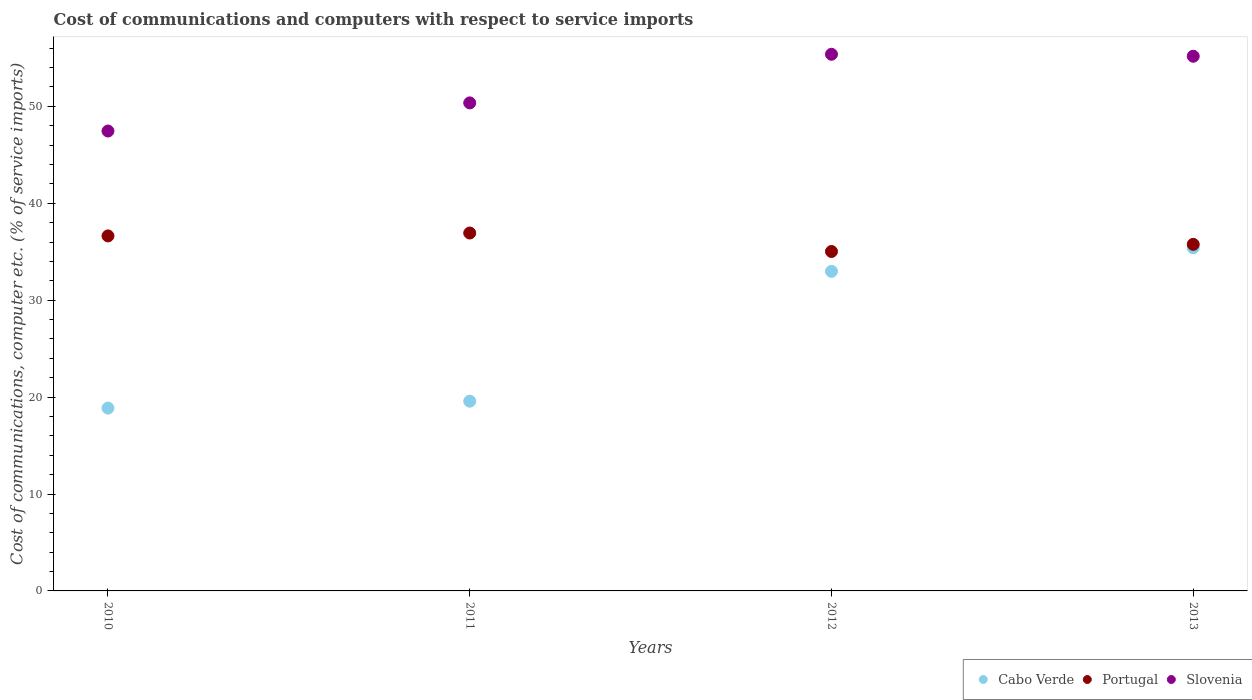How many different coloured dotlines are there?
Your answer should be compact. 3. What is the cost of communications and computers in Slovenia in 2011?
Your response must be concise. 50.35. Across all years, what is the maximum cost of communications and computers in Slovenia?
Provide a short and direct response. 55.37. Across all years, what is the minimum cost of communications and computers in Portugal?
Offer a terse response. 35.02. What is the total cost of communications and computers in Portugal in the graph?
Your answer should be compact. 144.34. What is the difference between the cost of communications and computers in Slovenia in 2010 and that in 2011?
Make the answer very short. -2.9. What is the difference between the cost of communications and computers in Cabo Verde in 2011 and the cost of communications and computers in Slovenia in 2010?
Your answer should be compact. -27.87. What is the average cost of communications and computers in Cabo Verde per year?
Your answer should be compact. 26.7. In the year 2012, what is the difference between the cost of communications and computers in Portugal and cost of communications and computers in Slovenia?
Your answer should be very brief. -20.35. What is the ratio of the cost of communications and computers in Slovenia in 2010 to that in 2011?
Keep it short and to the point. 0.94. Is the difference between the cost of communications and computers in Portugal in 2010 and 2012 greater than the difference between the cost of communications and computers in Slovenia in 2010 and 2012?
Offer a terse response. Yes. What is the difference between the highest and the second highest cost of communications and computers in Cabo Verde?
Make the answer very short. 2.43. What is the difference between the highest and the lowest cost of communications and computers in Portugal?
Offer a terse response. 1.91. Is the cost of communications and computers in Portugal strictly greater than the cost of communications and computers in Cabo Verde over the years?
Make the answer very short. Yes. How many years are there in the graph?
Provide a short and direct response. 4. Are the values on the major ticks of Y-axis written in scientific E-notation?
Provide a short and direct response. No. Does the graph contain grids?
Your answer should be very brief. No. Where does the legend appear in the graph?
Give a very brief answer. Bottom right. How many legend labels are there?
Your answer should be compact. 3. How are the legend labels stacked?
Make the answer very short. Horizontal. What is the title of the graph?
Ensure brevity in your answer.  Cost of communications and computers with respect to service imports. Does "Cabo Verde" appear as one of the legend labels in the graph?
Your answer should be compact. Yes. What is the label or title of the X-axis?
Provide a short and direct response. Years. What is the label or title of the Y-axis?
Ensure brevity in your answer.  Cost of communications, computer etc. (% of service imports). What is the Cost of communications, computer etc. (% of service imports) of Cabo Verde in 2010?
Your answer should be very brief. 18.86. What is the Cost of communications, computer etc. (% of service imports) of Portugal in 2010?
Provide a short and direct response. 36.63. What is the Cost of communications, computer etc. (% of service imports) of Slovenia in 2010?
Your answer should be compact. 47.45. What is the Cost of communications, computer etc. (% of service imports) of Cabo Verde in 2011?
Give a very brief answer. 19.58. What is the Cost of communications, computer etc. (% of service imports) in Portugal in 2011?
Provide a succinct answer. 36.93. What is the Cost of communications, computer etc. (% of service imports) in Slovenia in 2011?
Give a very brief answer. 50.35. What is the Cost of communications, computer etc. (% of service imports) in Cabo Verde in 2012?
Your response must be concise. 32.97. What is the Cost of communications, computer etc. (% of service imports) in Portugal in 2012?
Provide a succinct answer. 35.02. What is the Cost of communications, computer etc. (% of service imports) of Slovenia in 2012?
Offer a terse response. 55.37. What is the Cost of communications, computer etc. (% of service imports) of Cabo Verde in 2013?
Offer a terse response. 35.4. What is the Cost of communications, computer etc. (% of service imports) of Portugal in 2013?
Make the answer very short. 35.76. What is the Cost of communications, computer etc. (% of service imports) of Slovenia in 2013?
Offer a terse response. 55.17. Across all years, what is the maximum Cost of communications, computer etc. (% of service imports) in Cabo Verde?
Offer a very short reply. 35.4. Across all years, what is the maximum Cost of communications, computer etc. (% of service imports) of Portugal?
Offer a terse response. 36.93. Across all years, what is the maximum Cost of communications, computer etc. (% of service imports) in Slovenia?
Give a very brief answer. 55.37. Across all years, what is the minimum Cost of communications, computer etc. (% of service imports) in Cabo Verde?
Keep it short and to the point. 18.86. Across all years, what is the minimum Cost of communications, computer etc. (% of service imports) in Portugal?
Offer a very short reply. 35.02. Across all years, what is the minimum Cost of communications, computer etc. (% of service imports) of Slovenia?
Your answer should be compact. 47.45. What is the total Cost of communications, computer etc. (% of service imports) of Cabo Verde in the graph?
Your answer should be compact. 106.81. What is the total Cost of communications, computer etc. (% of service imports) of Portugal in the graph?
Provide a succinct answer. 144.34. What is the total Cost of communications, computer etc. (% of service imports) of Slovenia in the graph?
Keep it short and to the point. 208.34. What is the difference between the Cost of communications, computer etc. (% of service imports) in Cabo Verde in 2010 and that in 2011?
Provide a short and direct response. -0.71. What is the difference between the Cost of communications, computer etc. (% of service imports) in Portugal in 2010 and that in 2011?
Your response must be concise. -0.3. What is the difference between the Cost of communications, computer etc. (% of service imports) in Slovenia in 2010 and that in 2011?
Your answer should be compact. -2.9. What is the difference between the Cost of communications, computer etc. (% of service imports) in Cabo Verde in 2010 and that in 2012?
Your answer should be compact. -14.11. What is the difference between the Cost of communications, computer etc. (% of service imports) in Portugal in 2010 and that in 2012?
Offer a terse response. 1.61. What is the difference between the Cost of communications, computer etc. (% of service imports) in Slovenia in 2010 and that in 2012?
Your answer should be compact. -7.92. What is the difference between the Cost of communications, computer etc. (% of service imports) in Cabo Verde in 2010 and that in 2013?
Provide a succinct answer. -16.54. What is the difference between the Cost of communications, computer etc. (% of service imports) of Portugal in 2010 and that in 2013?
Give a very brief answer. 0.87. What is the difference between the Cost of communications, computer etc. (% of service imports) of Slovenia in 2010 and that in 2013?
Offer a very short reply. -7.72. What is the difference between the Cost of communications, computer etc. (% of service imports) of Cabo Verde in 2011 and that in 2012?
Provide a succinct answer. -13.4. What is the difference between the Cost of communications, computer etc. (% of service imports) in Portugal in 2011 and that in 2012?
Your answer should be very brief. 1.91. What is the difference between the Cost of communications, computer etc. (% of service imports) of Slovenia in 2011 and that in 2012?
Offer a terse response. -5.02. What is the difference between the Cost of communications, computer etc. (% of service imports) in Cabo Verde in 2011 and that in 2013?
Provide a short and direct response. -15.83. What is the difference between the Cost of communications, computer etc. (% of service imports) of Portugal in 2011 and that in 2013?
Offer a terse response. 1.17. What is the difference between the Cost of communications, computer etc. (% of service imports) in Slovenia in 2011 and that in 2013?
Ensure brevity in your answer.  -4.81. What is the difference between the Cost of communications, computer etc. (% of service imports) of Cabo Verde in 2012 and that in 2013?
Provide a succinct answer. -2.43. What is the difference between the Cost of communications, computer etc. (% of service imports) of Portugal in 2012 and that in 2013?
Give a very brief answer. -0.74. What is the difference between the Cost of communications, computer etc. (% of service imports) in Slovenia in 2012 and that in 2013?
Offer a terse response. 0.2. What is the difference between the Cost of communications, computer etc. (% of service imports) of Cabo Verde in 2010 and the Cost of communications, computer etc. (% of service imports) of Portugal in 2011?
Keep it short and to the point. -18.06. What is the difference between the Cost of communications, computer etc. (% of service imports) in Cabo Verde in 2010 and the Cost of communications, computer etc. (% of service imports) in Slovenia in 2011?
Give a very brief answer. -31.49. What is the difference between the Cost of communications, computer etc. (% of service imports) in Portugal in 2010 and the Cost of communications, computer etc. (% of service imports) in Slovenia in 2011?
Provide a short and direct response. -13.72. What is the difference between the Cost of communications, computer etc. (% of service imports) of Cabo Verde in 2010 and the Cost of communications, computer etc. (% of service imports) of Portugal in 2012?
Your response must be concise. -16.16. What is the difference between the Cost of communications, computer etc. (% of service imports) of Cabo Verde in 2010 and the Cost of communications, computer etc. (% of service imports) of Slovenia in 2012?
Your answer should be very brief. -36.51. What is the difference between the Cost of communications, computer etc. (% of service imports) in Portugal in 2010 and the Cost of communications, computer etc. (% of service imports) in Slovenia in 2012?
Make the answer very short. -18.74. What is the difference between the Cost of communications, computer etc. (% of service imports) of Cabo Verde in 2010 and the Cost of communications, computer etc. (% of service imports) of Portugal in 2013?
Your answer should be very brief. -16.9. What is the difference between the Cost of communications, computer etc. (% of service imports) of Cabo Verde in 2010 and the Cost of communications, computer etc. (% of service imports) of Slovenia in 2013?
Provide a succinct answer. -36.3. What is the difference between the Cost of communications, computer etc. (% of service imports) in Portugal in 2010 and the Cost of communications, computer etc. (% of service imports) in Slovenia in 2013?
Your response must be concise. -18.54. What is the difference between the Cost of communications, computer etc. (% of service imports) in Cabo Verde in 2011 and the Cost of communications, computer etc. (% of service imports) in Portugal in 2012?
Your response must be concise. -15.45. What is the difference between the Cost of communications, computer etc. (% of service imports) of Cabo Verde in 2011 and the Cost of communications, computer etc. (% of service imports) of Slovenia in 2012?
Offer a very short reply. -35.79. What is the difference between the Cost of communications, computer etc. (% of service imports) of Portugal in 2011 and the Cost of communications, computer etc. (% of service imports) of Slovenia in 2012?
Ensure brevity in your answer.  -18.44. What is the difference between the Cost of communications, computer etc. (% of service imports) of Cabo Verde in 2011 and the Cost of communications, computer etc. (% of service imports) of Portugal in 2013?
Your answer should be very brief. -16.18. What is the difference between the Cost of communications, computer etc. (% of service imports) in Cabo Verde in 2011 and the Cost of communications, computer etc. (% of service imports) in Slovenia in 2013?
Provide a short and direct response. -35.59. What is the difference between the Cost of communications, computer etc. (% of service imports) in Portugal in 2011 and the Cost of communications, computer etc. (% of service imports) in Slovenia in 2013?
Your response must be concise. -18.24. What is the difference between the Cost of communications, computer etc. (% of service imports) of Cabo Verde in 2012 and the Cost of communications, computer etc. (% of service imports) of Portugal in 2013?
Provide a succinct answer. -2.79. What is the difference between the Cost of communications, computer etc. (% of service imports) in Cabo Verde in 2012 and the Cost of communications, computer etc. (% of service imports) in Slovenia in 2013?
Your answer should be very brief. -22.2. What is the difference between the Cost of communications, computer etc. (% of service imports) of Portugal in 2012 and the Cost of communications, computer etc. (% of service imports) of Slovenia in 2013?
Offer a terse response. -20.15. What is the average Cost of communications, computer etc. (% of service imports) of Cabo Verde per year?
Provide a succinct answer. 26.7. What is the average Cost of communications, computer etc. (% of service imports) in Portugal per year?
Keep it short and to the point. 36.08. What is the average Cost of communications, computer etc. (% of service imports) of Slovenia per year?
Make the answer very short. 52.09. In the year 2010, what is the difference between the Cost of communications, computer etc. (% of service imports) of Cabo Verde and Cost of communications, computer etc. (% of service imports) of Portugal?
Make the answer very short. -17.77. In the year 2010, what is the difference between the Cost of communications, computer etc. (% of service imports) in Cabo Verde and Cost of communications, computer etc. (% of service imports) in Slovenia?
Ensure brevity in your answer.  -28.59. In the year 2010, what is the difference between the Cost of communications, computer etc. (% of service imports) of Portugal and Cost of communications, computer etc. (% of service imports) of Slovenia?
Your answer should be compact. -10.82. In the year 2011, what is the difference between the Cost of communications, computer etc. (% of service imports) of Cabo Verde and Cost of communications, computer etc. (% of service imports) of Portugal?
Ensure brevity in your answer.  -17.35. In the year 2011, what is the difference between the Cost of communications, computer etc. (% of service imports) of Cabo Verde and Cost of communications, computer etc. (% of service imports) of Slovenia?
Your response must be concise. -30.78. In the year 2011, what is the difference between the Cost of communications, computer etc. (% of service imports) of Portugal and Cost of communications, computer etc. (% of service imports) of Slovenia?
Your answer should be compact. -13.43. In the year 2012, what is the difference between the Cost of communications, computer etc. (% of service imports) in Cabo Verde and Cost of communications, computer etc. (% of service imports) in Portugal?
Provide a short and direct response. -2.05. In the year 2012, what is the difference between the Cost of communications, computer etc. (% of service imports) in Cabo Verde and Cost of communications, computer etc. (% of service imports) in Slovenia?
Your answer should be very brief. -22.4. In the year 2012, what is the difference between the Cost of communications, computer etc. (% of service imports) in Portugal and Cost of communications, computer etc. (% of service imports) in Slovenia?
Keep it short and to the point. -20.35. In the year 2013, what is the difference between the Cost of communications, computer etc. (% of service imports) in Cabo Verde and Cost of communications, computer etc. (% of service imports) in Portugal?
Your answer should be very brief. -0.36. In the year 2013, what is the difference between the Cost of communications, computer etc. (% of service imports) of Cabo Verde and Cost of communications, computer etc. (% of service imports) of Slovenia?
Offer a very short reply. -19.77. In the year 2013, what is the difference between the Cost of communications, computer etc. (% of service imports) in Portugal and Cost of communications, computer etc. (% of service imports) in Slovenia?
Offer a terse response. -19.41. What is the ratio of the Cost of communications, computer etc. (% of service imports) in Cabo Verde in 2010 to that in 2011?
Give a very brief answer. 0.96. What is the ratio of the Cost of communications, computer etc. (% of service imports) of Slovenia in 2010 to that in 2011?
Your answer should be compact. 0.94. What is the ratio of the Cost of communications, computer etc. (% of service imports) of Cabo Verde in 2010 to that in 2012?
Keep it short and to the point. 0.57. What is the ratio of the Cost of communications, computer etc. (% of service imports) of Portugal in 2010 to that in 2012?
Provide a succinct answer. 1.05. What is the ratio of the Cost of communications, computer etc. (% of service imports) in Slovenia in 2010 to that in 2012?
Offer a very short reply. 0.86. What is the ratio of the Cost of communications, computer etc. (% of service imports) of Cabo Verde in 2010 to that in 2013?
Offer a very short reply. 0.53. What is the ratio of the Cost of communications, computer etc. (% of service imports) of Portugal in 2010 to that in 2013?
Your answer should be compact. 1.02. What is the ratio of the Cost of communications, computer etc. (% of service imports) of Slovenia in 2010 to that in 2013?
Offer a very short reply. 0.86. What is the ratio of the Cost of communications, computer etc. (% of service imports) of Cabo Verde in 2011 to that in 2012?
Provide a succinct answer. 0.59. What is the ratio of the Cost of communications, computer etc. (% of service imports) of Portugal in 2011 to that in 2012?
Offer a very short reply. 1.05. What is the ratio of the Cost of communications, computer etc. (% of service imports) of Slovenia in 2011 to that in 2012?
Provide a succinct answer. 0.91. What is the ratio of the Cost of communications, computer etc. (% of service imports) in Cabo Verde in 2011 to that in 2013?
Your answer should be very brief. 0.55. What is the ratio of the Cost of communications, computer etc. (% of service imports) in Portugal in 2011 to that in 2013?
Your answer should be very brief. 1.03. What is the ratio of the Cost of communications, computer etc. (% of service imports) in Slovenia in 2011 to that in 2013?
Offer a very short reply. 0.91. What is the ratio of the Cost of communications, computer etc. (% of service imports) of Cabo Verde in 2012 to that in 2013?
Your response must be concise. 0.93. What is the ratio of the Cost of communications, computer etc. (% of service imports) of Portugal in 2012 to that in 2013?
Provide a short and direct response. 0.98. What is the ratio of the Cost of communications, computer etc. (% of service imports) of Slovenia in 2012 to that in 2013?
Offer a very short reply. 1. What is the difference between the highest and the second highest Cost of communications, computer etc. (% of service imports) in Cabo Verde?
Ensure brevity in your answer.  2.43. What is the difference between the highest and the second highest Cost of communications, computer etc. (% of service imports) of Portugal?
Offer a very short reply. 0.3. What is the difference between the highest and the second highest Cost of communications, computer etc. (% of service imports) in Slovenia?
Provide a succinct answer. 0.2. What is the difference between the highest and the lowest Cost of communications, computer etc. (% of service imports) in Cabo Verde?
Make the answer very short. 16.54. What is the difference between the highest and the lowest Cost of communications, computer etc. (% of service imports) in Portugal?
Your response must be concise. 1.91. What is the difference between the highest and the lowest Cost of communications, computer etc. (% of service imports) of Slovenia?
Provide a short and direct response. 7.92. 